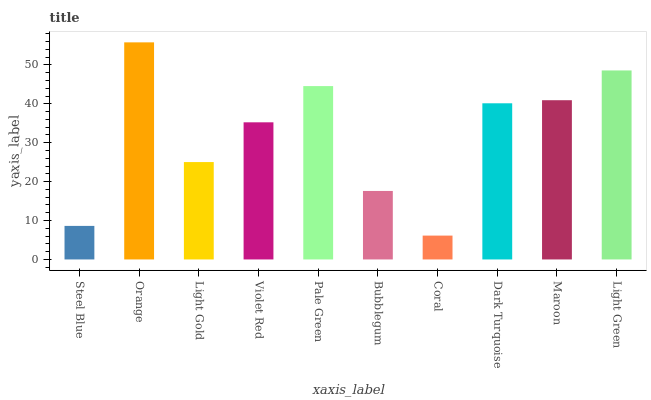Is Coral the minimum?
Answer yes or no. Yes. Is Orange the maximum?
Answer yes or no. Yes. Is Light Gold the minimum?
Answer yes or no. No. Is Light Gold the maximum?
Answer yes or no. No. Is Orange greater than Light Gold?
Answer yes or no. Yes. Is Light Gold less than Orange?
Answer yes or no. Yes. Is Light Gold greater than Orange?
Answer yes or no. No. Is Orange less than Light Gold?
Answer yes or no. No. Is Dark Turquoise the high median?
Answer yes or no. Yes. Is Violet Red the low median?
Answer yes or no. Yes. Is Coral the high median?
Answer yes or no. No. Is Light Green the low median?
Answer yes or no. No. 